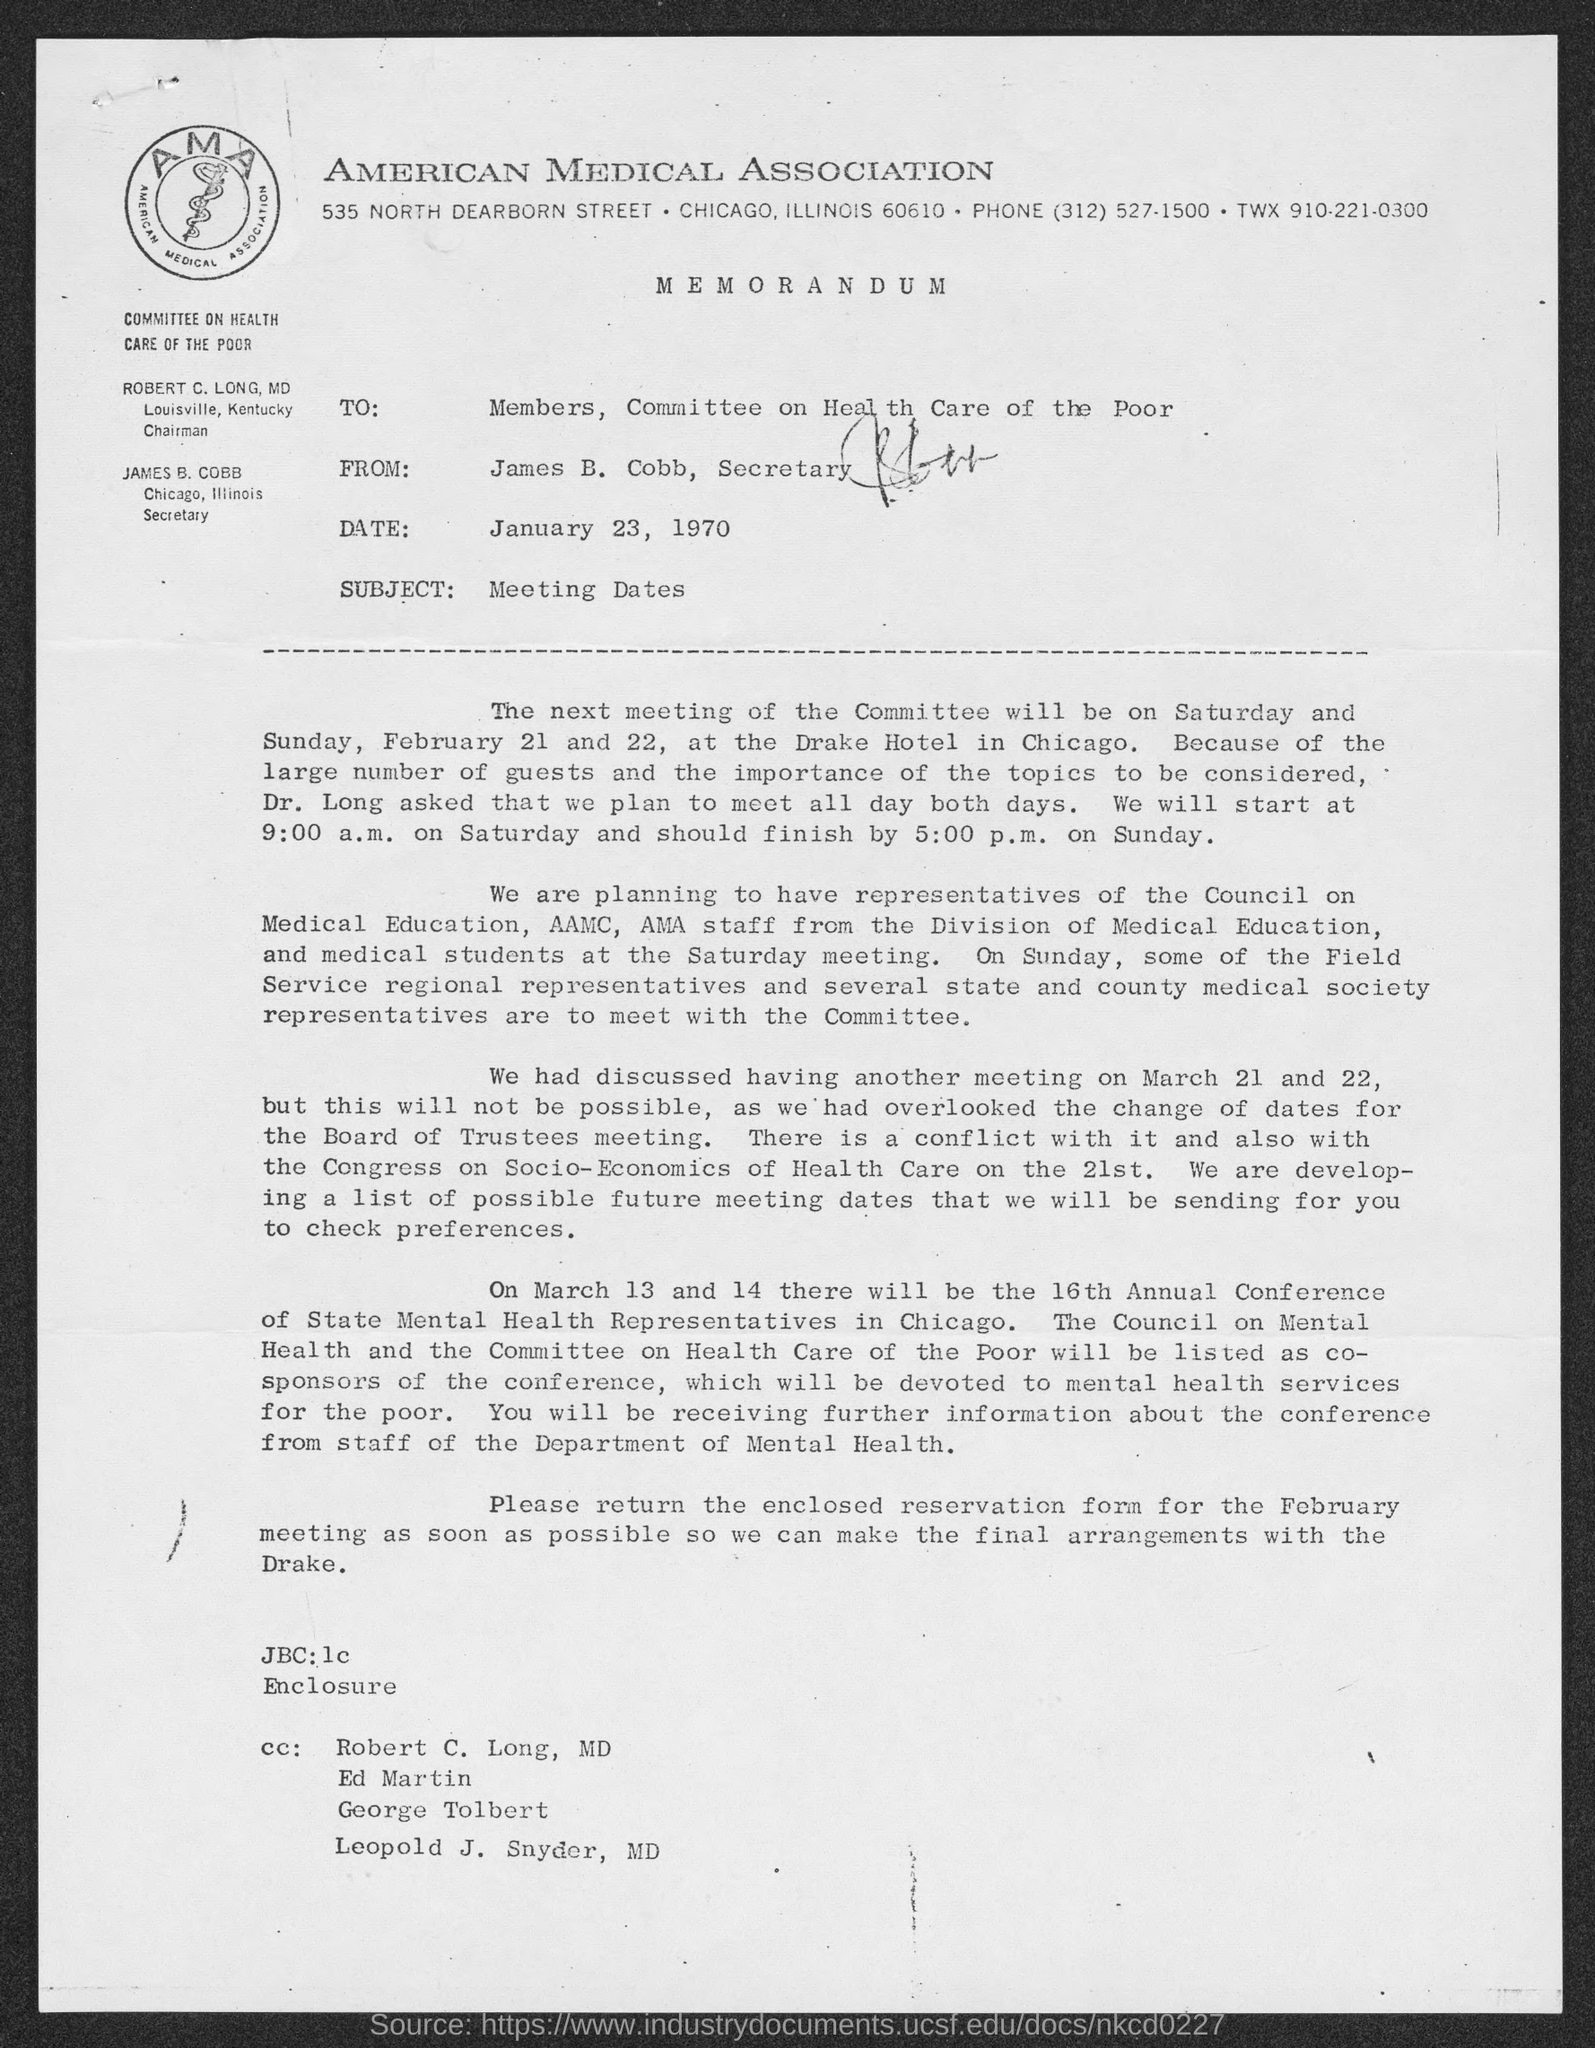In which city is american medical association at ?
Offer a terse response. Chicago. When is the memorandum dated?
Your response must be concise. January 23, 1970. What is the subject of the memorandum?
Keep it short and to the point. Meeting dates. What is the from address of memorandum ?
Your answer should be compact. James b. cobb. What is the position james b. cobb?
Provide a short and direct response. Secretary. What is the twx no. of american medical association ?
Your answer should be very brief. 910.221.0300. 